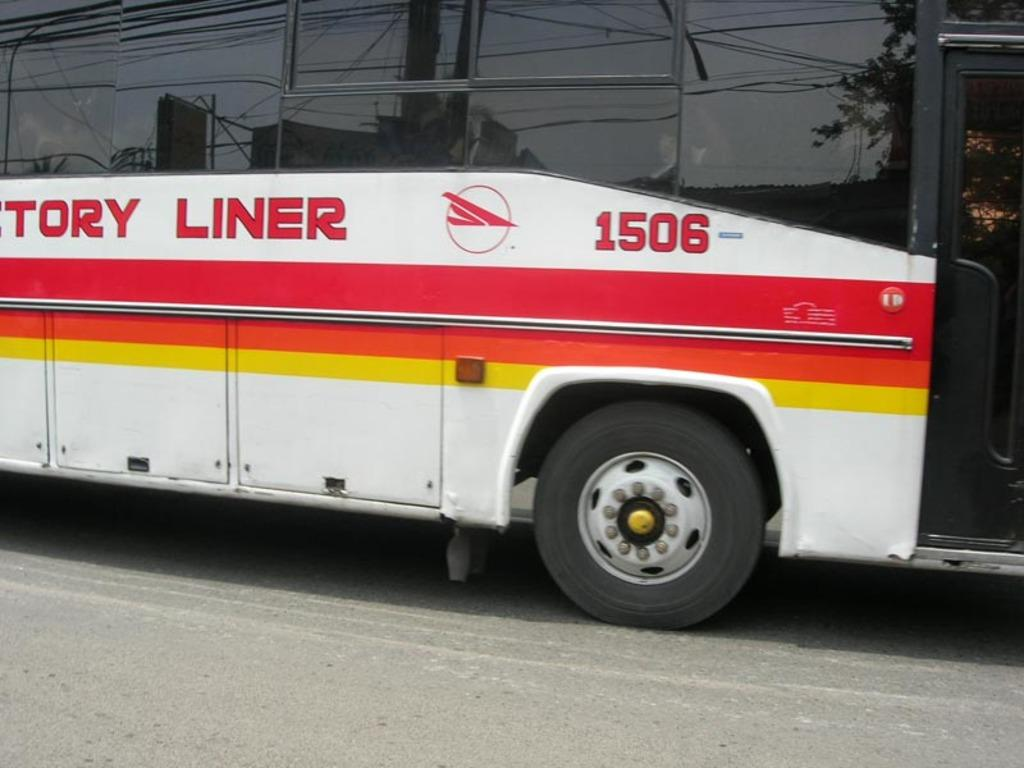What is the main subject of the image? The main subject of the image is a bus. Where is the bus located in the image? The bus is on the road in the image. What colors are used to paint the bus? The bus is painted with red, yellow, and white colors. Is there any text visible on the bus? Yes, there is some text in red color on the bus. What type of haircut does the bus have in the image? The bus does not have a haircut, as it is an inanimate object and not a living being. Can you describe the chin of the bus in the image? The bus does not have a chin, as it is a vehicle and not a living being. 